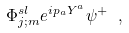Convert formula to latex. <formula><loc_0><loc_0><loc_500><loc_500>\Phi ^ { s l } _ { j ; m } e ^ { i p _ { a } Y ^ { a } } \psi ^ { + } \ ,</formula> 